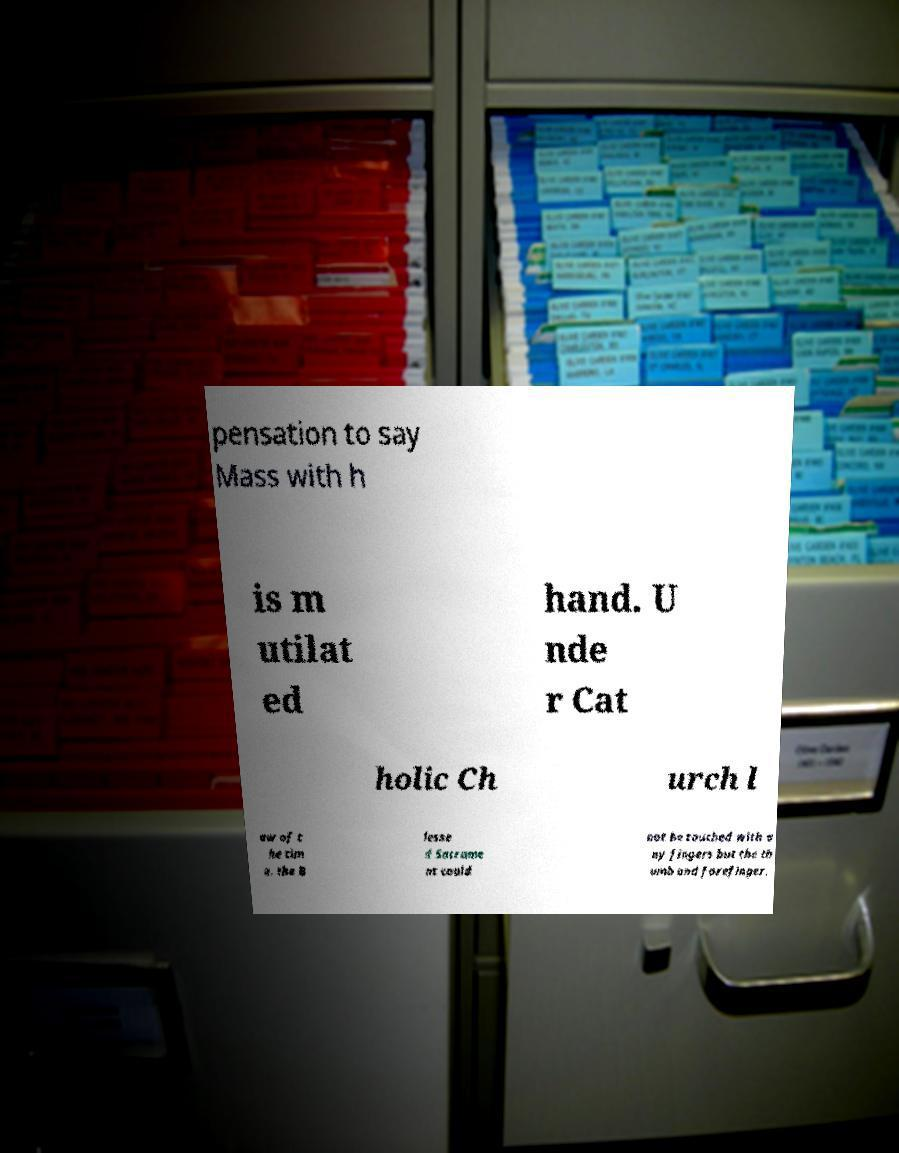I need the written content from this picture converted into text. Can you do that? pensation to say Mass with h is m utilat ed hand. U nde r Cat holic Ch urch l aw of t he tim e, the B lesse d Sacrame nt could not be touched with a ny fingers but the th umb and forefinger. 